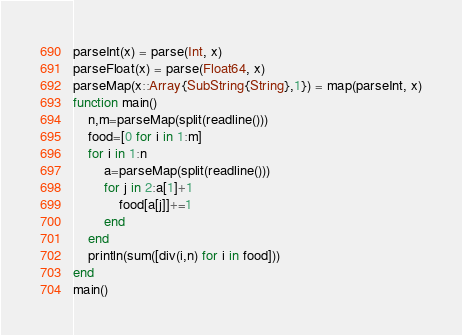<code> <loc_0><loc_0><loc_500><loc_500><_Julia_>parseInt(x) = parse(Int, x)
parseFloat(x) = parse(Float64, x)
parseMap(x::Array{SubString{String},1}) = map(parseInt, x)
function main()
    n,m=parseMap(split(readline()))
    food=[0 for i in 1:m]
    for i in 1:n
        a=parseMap(split(readline()))
        for j in 2:a[1]+1
            food[a[j]]+=1
        end
    end
    println(sum([div(i,n) for i in food]))
end
main()</code> 